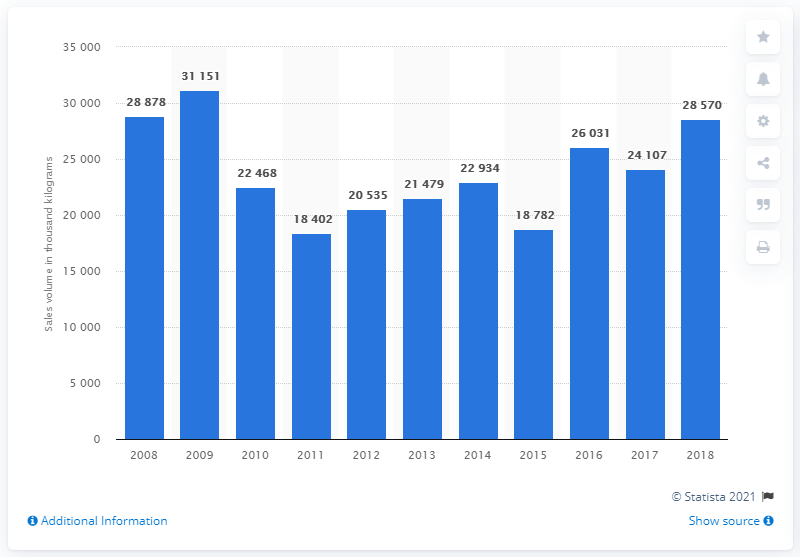What was the sales volume of mixed fruit and nuts in 2018?
 28878 